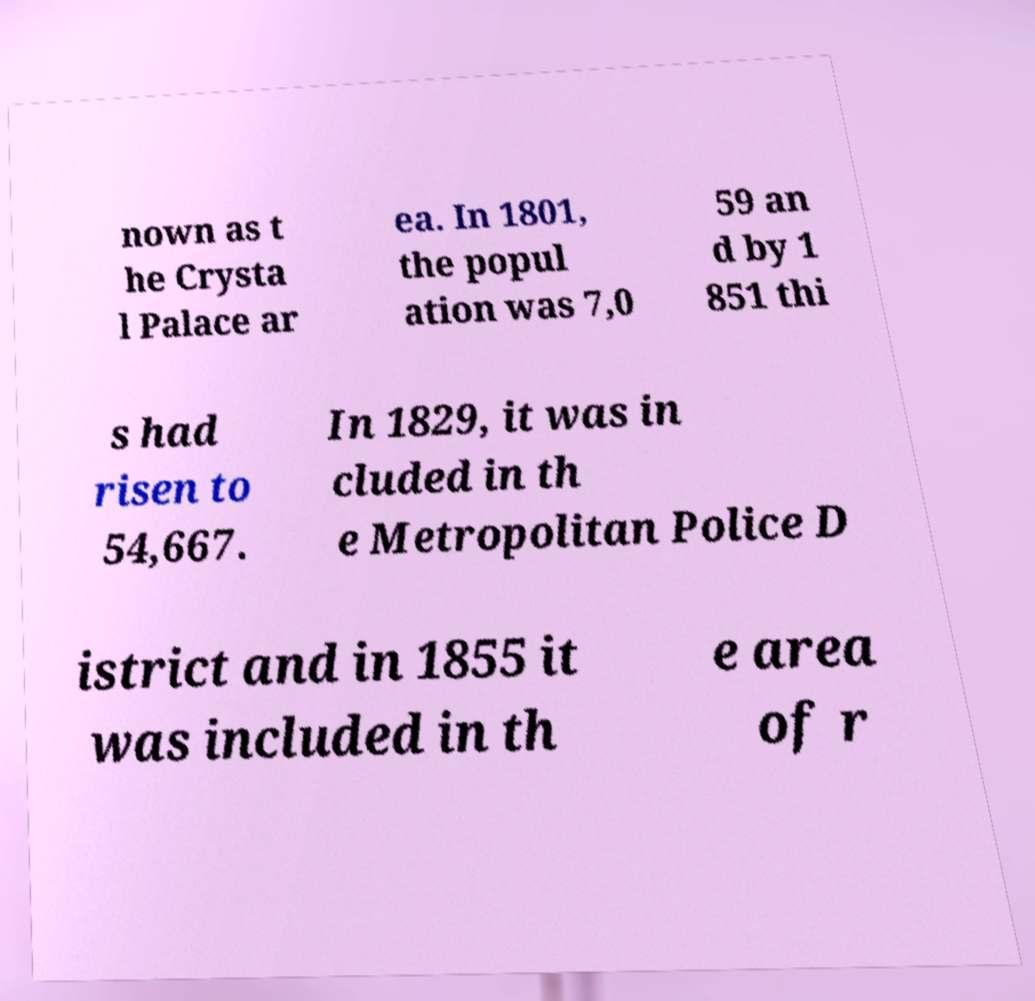I need the written content from this picture converted into text. Can you do that? nown as t he Crysta l Palace ar ea. In 1801, the popul ation was 7,0 59 an d by 1 851 thi s had risen to 54,667. In 1829, it was in cluded in th e Metropolitan Police D istrict and in 1855 it was included in th e area of r 